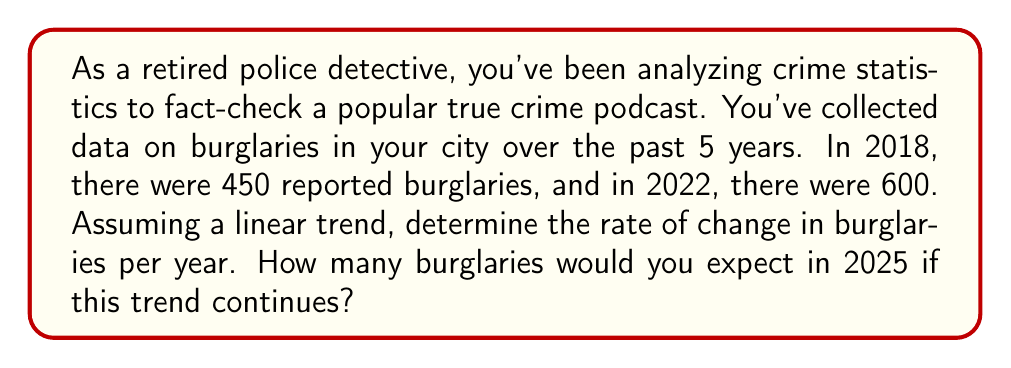Help me with this question. Let's approach this step-by-step:

1) First, we need to calculate the rate of change (slope) of the linear equation.
   The slope formula is: $m = \frac{y_2 - y_1}{x_2 - x_1}$

   Where:
   $x_1 = 2018$, $y_1 = 450$
   $x_2 = 2022$, $y_2 = 600$

2) Plugging these values into the formula:

   $m = \frac{600 - 450}{2022 - 2018} = \frac{150}{4} = 37.5$

   This means the number of burglaries is increasing by 37.5 per year.

3) Now that we have the rate of change, we can use the point-slope form of a linear equation to find the number of burglaries in 2025:

   $y - y_1 = m(x - x_1)$

   Let's use the 2018 data point: $(2018, 450)$

   $y - 450 = 37.5(x - 2018)$

4) To find the number of burglaries in 2025, we plug in $x = 2025$:

   $y - 450 = 37.5(2025 - 2018)$
   $y - 450 = 37.5(7)$
   $y - 450 = 262.5$
   $y = 712.5$

5) Since we're dealing with whole numbers of burglaries, we round to the nearest integer: 713.
Answer: 37.5 burglaries/year; 713 burglaries in 2025 